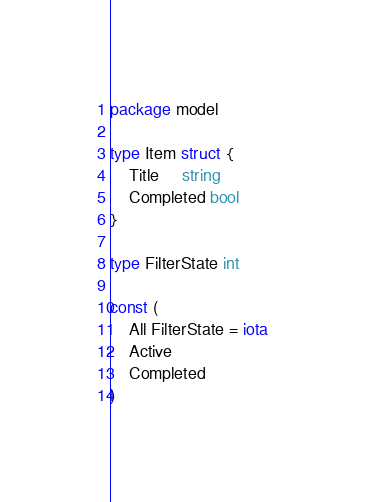<code> <loc_0><loc_0><loc_500><loc_500><_Go_>package model

type Item struct {
	Title     string
	Completed bool
}

type FilterState int

const (
	All FilterState = iota
	Active
	Completed
)
</code> 